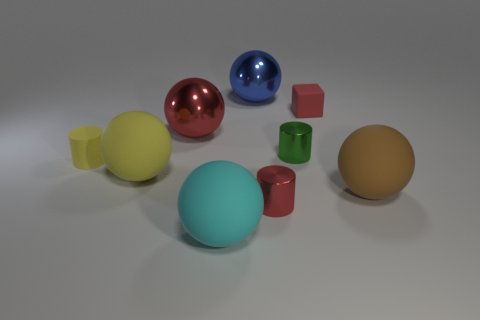Subtract all yellow cylinders. How many cylinders are left? 2 Add 1 large purple shiny blocks. How many objects exist? 10 Subtract all yellow cylinders. How many cylinders are left? 2 Subtract all cubes. How many objects are left? 8 Subtract all cyan cubes. Subtract all blue metallic balls. How many objects are left? 8 Add 9 brown spheres. How many brown spheres are left? 10 Add 8 tiny matte cylinders. How many tiny matte cylinders exist? 9 Subtract 1 green cylinders. How many objects are left? 8 Subtract 1 cylinders. How many cylinders are left? 2 Subtract all blue cylinders. Subtract all green blocks. How many cylinders are left? 3 